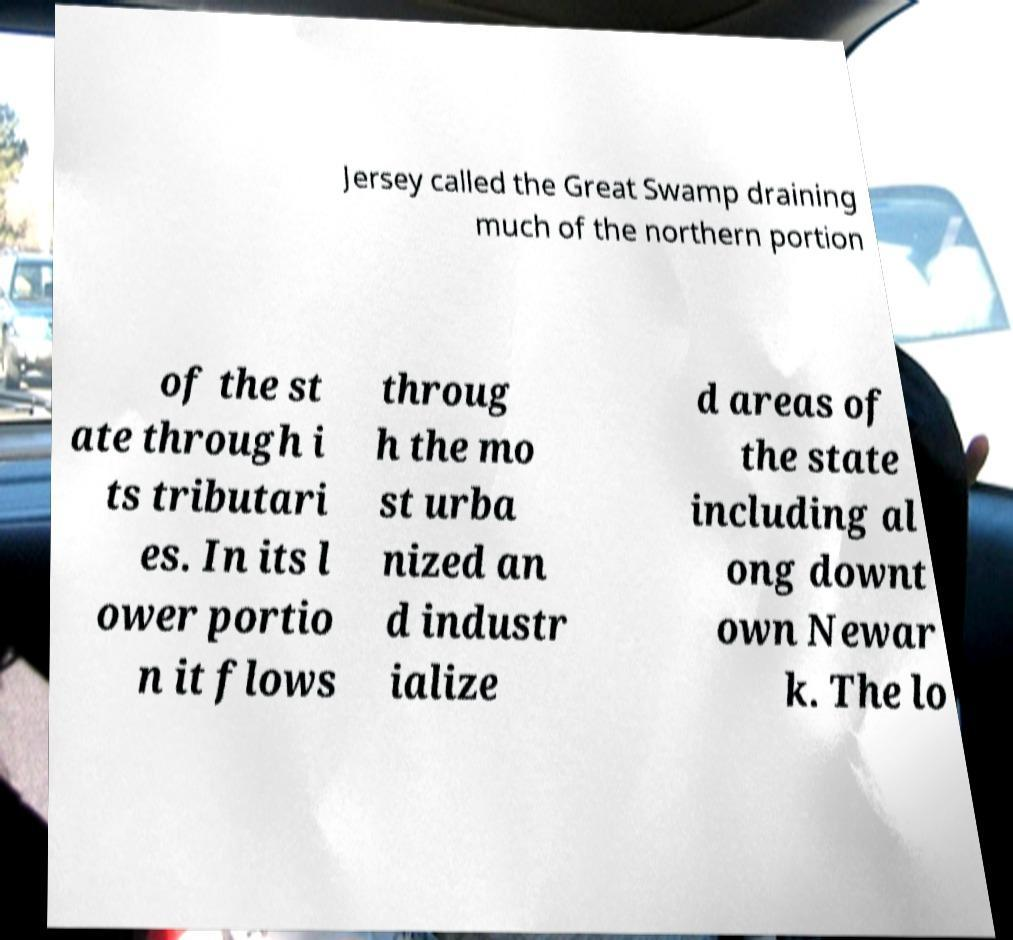Please read and relay the text visible in this image. What does it say? Jersey called the Great Swamp draining much of the northern portion of the st ate through i ts tributari es. In its l ower portio n it flows throug h the mo st urba nized an d industr ialize d areas of the state including al ong downt own Newar k. The lo 